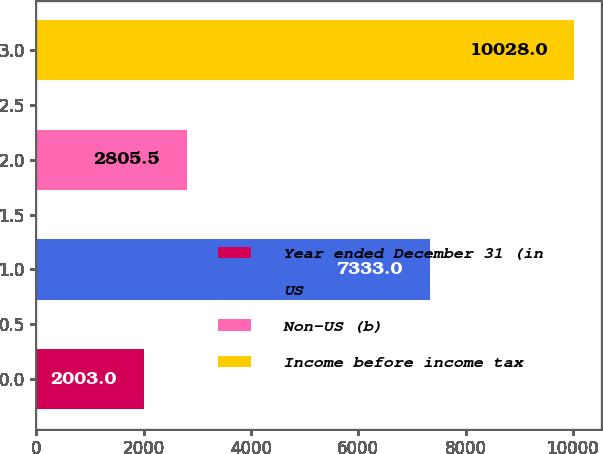<chart> <loc_0><loc_0><loc_500><loc_500><bar_chart><fcel>Year ended December 31 (in<fcel>US<fcel>Non-US (b)<fcel>Income before income tax<nl><fcel>2003<fcel>7333<fcel>2805.5<fcel>10028<nl></chart> 